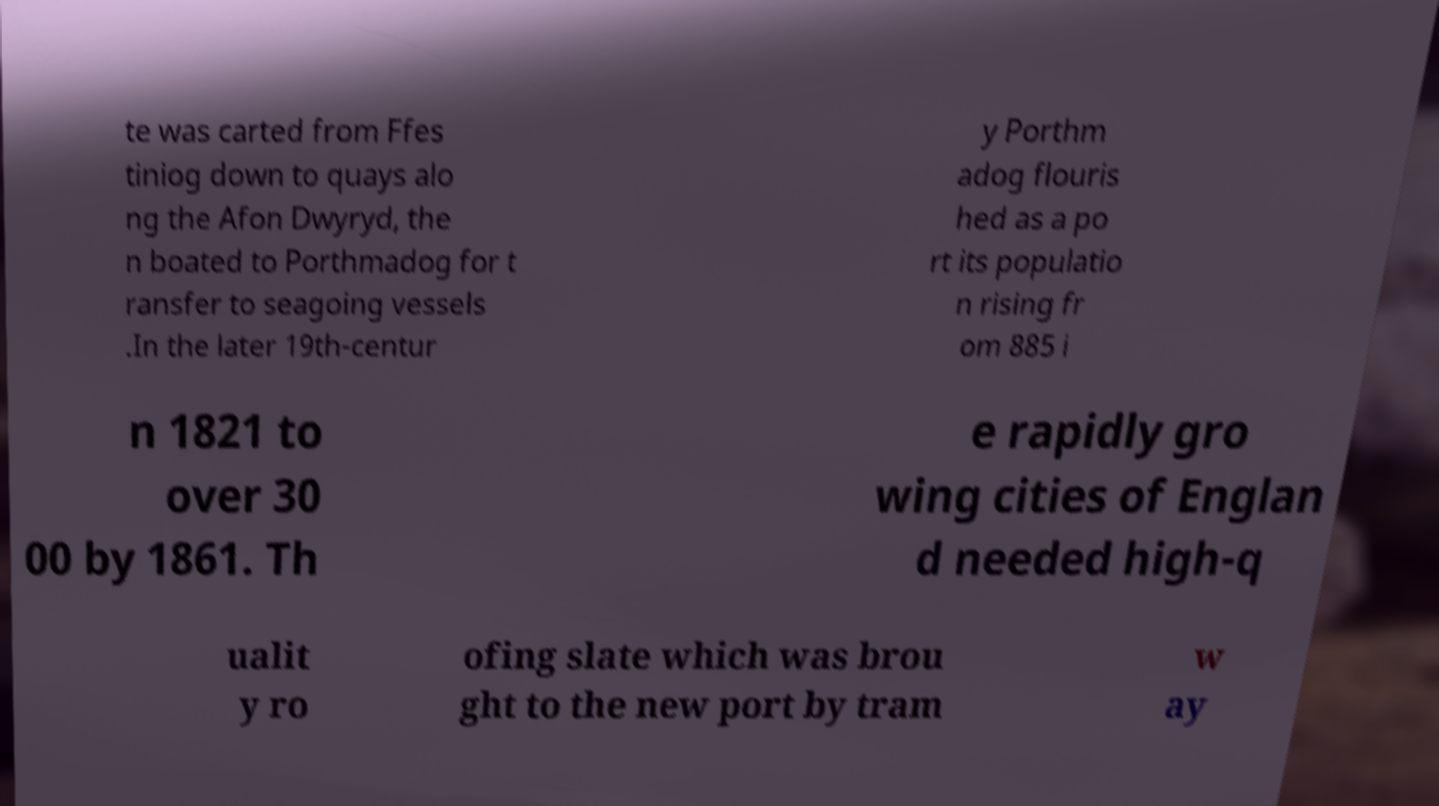Can you read and provide the text displayed in the image?This photo seems to have some interesting text. Can you extract and type it out for me? te was carted from Ffes tiniog down to quays alo ng the Afon Dwyryd, the n boated to Porthmadog for t ransfer to seagoing vessels .In the later 19th-centur y Porthm adog flouris hed as a po rt its populatio n rising fr om 885 i n 1821 to over 30 00 by 1861. Th e rapidly gro wing cities of Englan d needed high-q ualit y ro ofing slate which was brou ght to the new port by tram w ay 